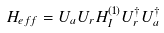<formula> <loc_0><loc_0><loc_500><loc_500>H _ { e f f } = U _ { a } U _ { r } H _ { I } ^ { \left ( 1 \right ) } U _ { r } ^ { \dagger } U _ { a } ^ { \dagger }</formula> 